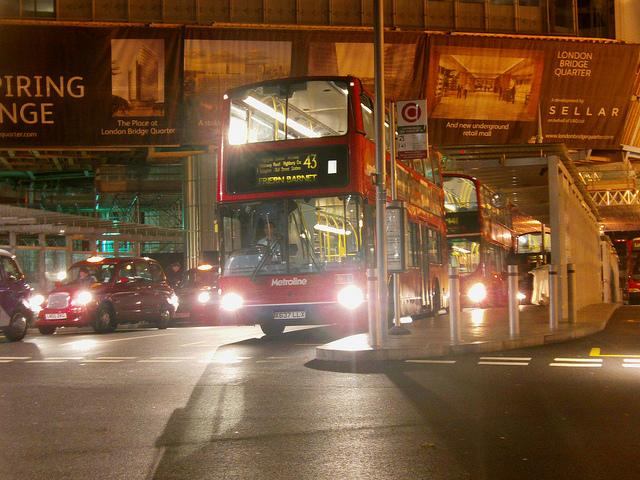What country is it? Please explain your reasoning. britain. London bridge quarter is shown on two different signs. 